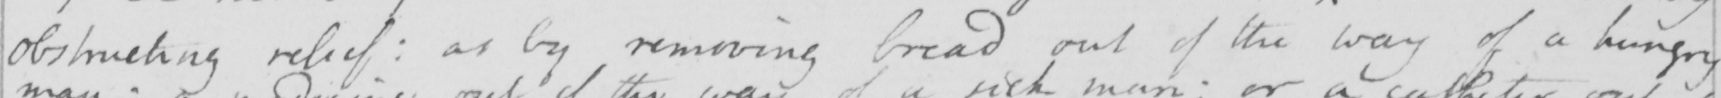What text is written in this handwritten line? obstructing relief :  as by removing bread out of the way of a hungry 